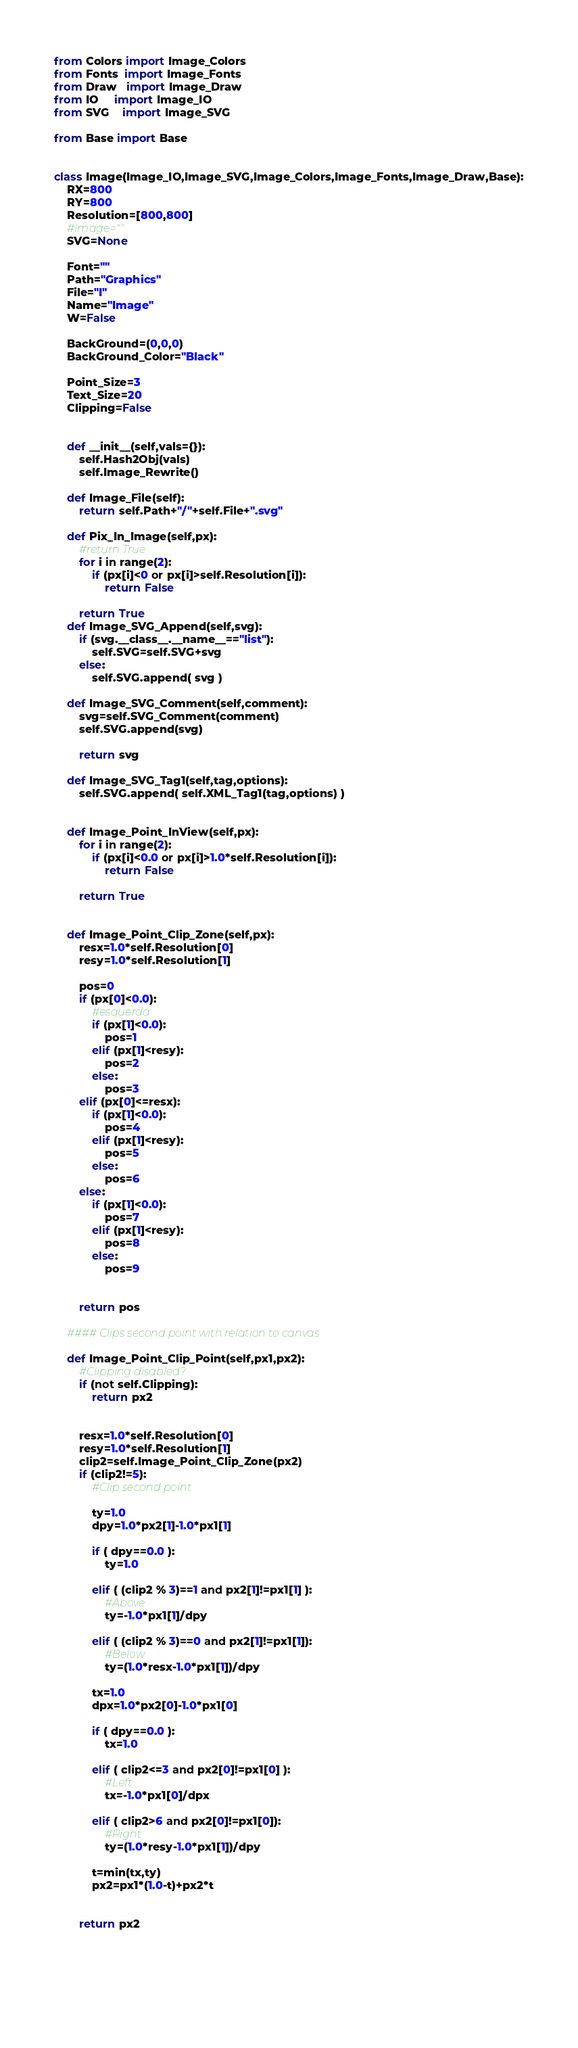Convert code to text. <code><loc_0><loc_0><loc_500><loc_500><_Python_>
from Colors import Image_Colors
from Fonts  import Image_Fonts
from Draw   import Image_Draw
from IO     import Image_IO
from SVG    import Image_SVG

from Base import Base


class Image(Image_IO,Image_SVG,Image_Colors,Image_Fonts,Image_Draw,Base):
    RX=800
    RY=800
    Resolution=[800,800]
    #Image=""
    SVG=None
    
    Font=""
    Path="Graphics"
    File="I"
    Name="Image"
    W=False

    BackGround=(0,0,0)
    BackGround_Color="Black"

    Point_Size=3
    Text_Size=20
    Clipping=False

    
    def __init__(self,vals={}):
        self.Hash2Obj(vals)
        self.Image_Rewrite()

    def Image_File(self):
        return self.Path+"/"+self.File+".svg"

    def Pix_In_Image(self,px):
        #return True
        for i in range(2):
            if (px[i]<0 or px[i]>self.Resolution[i]):
                return False

        return True
    def Image_SVG_Append(self,svg):
        if (svg.__class__.__name__=="list"):
            self.SVG=self.SVG+svg
        else:
            self.SVG.append( svg )
    
    def Image_SVG_Comment(self,comment):
        svg=self.SVG_Comment(comment)
        self.SVG.append(svg)

        return svg
   
    def Image_SVG_Tag1(self,tag,options):
        self.SVG.append( self.XML_Tag1(tag,options) )
   
   
    def Image_Point_InView(self,px):
        for i in range(2):
            if (px[i]<0.0 or px[i]>1.0*self.Resolution[i]):
                return False
            
        return True
       
   
    def Image_Point_Clip_Zone(self,px):
        resx=1.0*self.Resolution[0]
        resy=1.0*self.Resolution[1]

        pos=0
        if (px[0]<0.0):
            #esquerda
            if (px[1]<0.0):
                pos=1
            elif (px[1]<resy):
                pos=2
            else:
                pos=3
        elif (px[0]<=resx):
            if (px[1]<0.0):
                pos=4
            elif (px[1]<resy):
                pos=5
            else:
                pos=6
        else:
            if (px[1]<0.0):
                pos=7
            elif (px[1]<resy):
                pos=8
            else:
                pos=9

        
        return pos
    
    #### Clips second point with relation to canvas
   
    def Image_Point_Clip_Point(self,px1,px2):
        #Clipping disabled?
        if (not self.Clipping):
            return px2
    
        
        resx=1.0*self.Resolution[0]
        resy=1.0*self.Resolution[1]
        clip2=self.Image_Point_Clip_Zone(px2)
        if (clip2!=5):
            #Clip second point

            ty=1.0
            dpy=1.0*px2[1]-1.0*px1[1]
            
            if ( dpy==0.0 ):
                ty=1.0
                
            elif ( (clip2 % 3)==1 and px2[1]!=px1[1] ):
                #Above
                ty=-1.0*px1[1]/dpy
                
            elif ( (clip2 % 3)==0 and px2[1]!=px1[1]):
                #Below
                ty=(1.0*resx-1.0*px1[1])/dpy
                
            tx=1.0
            dpx=1.0*px2[0]-1.0*px1[0]
            
            if ( dpy==0.0 ):
                tx=1.0
                
            elif ( clip2<=3 and px2[0]!=px1[0] ):
                #Left
                tx=-1.0*px1[0]/dpx
                
            elif ( clip2>6 and px2[0]!=px1[0]):
                #Right
                ty=(1.0*resy-1.0*px1[1])/dpy
            
            t=min(tx,ty)
            px2=px1*(1.0-t)+px2*t


        return px2
        

       
   
    
</code> 